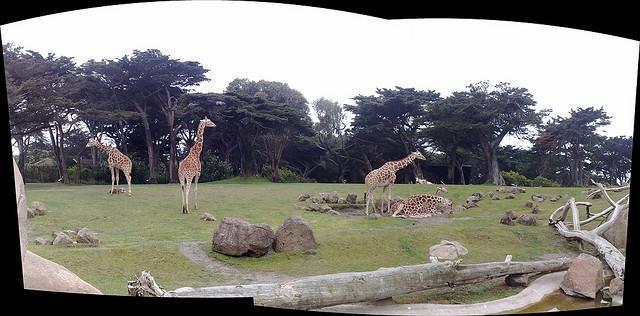How many animals are in the picture?
Give a very brief answer. 4. 